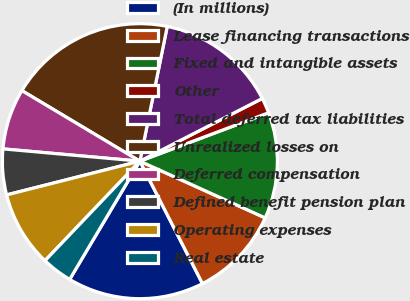Convert chart to OTSL. <chart><loc_0><loc_0><loc_500><loc_500><pie_chart><fcel>(In millions)<fcel>Lease financing transactions<fcel>Fixed and intangible assets<fcel>Other<fcel>Total deferred tax liabilities<fcel>Unrealized losses on<fcel>Deferred compensation<fcel>Defined benefit pension plan<fcel>Operating expenses<fcel>Real estate<nl><fcel>16.05%<fcel>10.71%<fcel>12.49%<fcel>1.81%<fcel>14.27%<fcel>19.61%<fcel>7.15%<fcel>5.37%<fcel>8.93%<fcel>3.59%<nl></chart> 